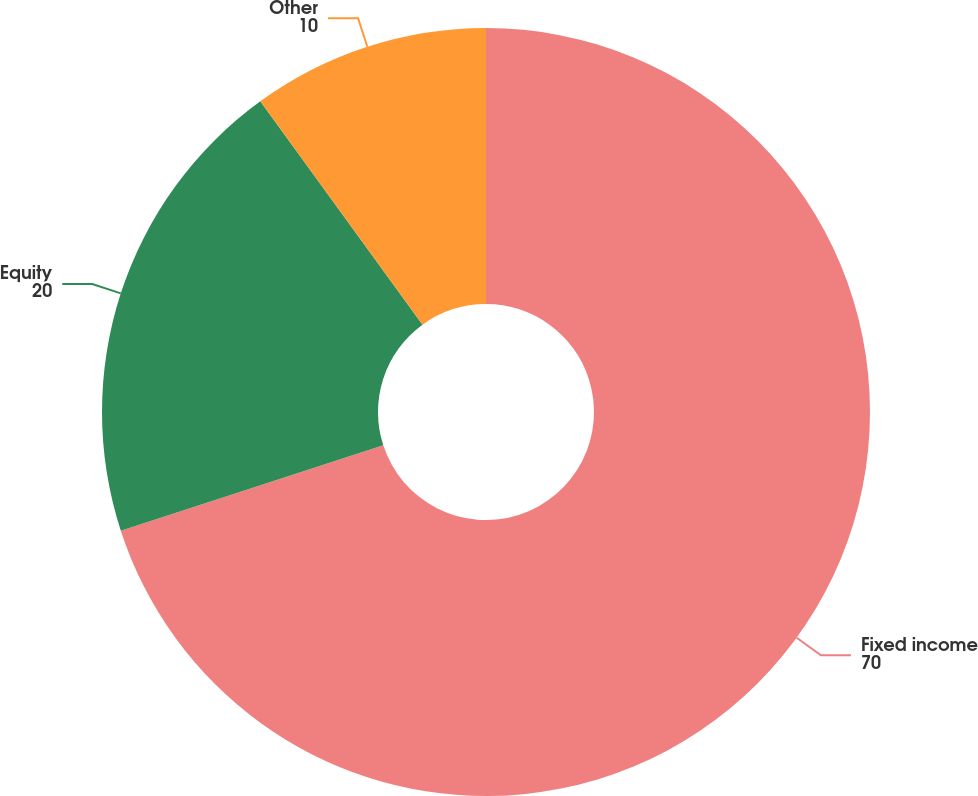Convert chart to OTSL. <chart><loc_0><loc_0><loc_500><loc_500><pie_chart><fcel>Fixed income<fcel>Equity<fcel>Other<nl><fcel>70.0%<fcel>20.0%<fcel>10.0%<nl></chart> 